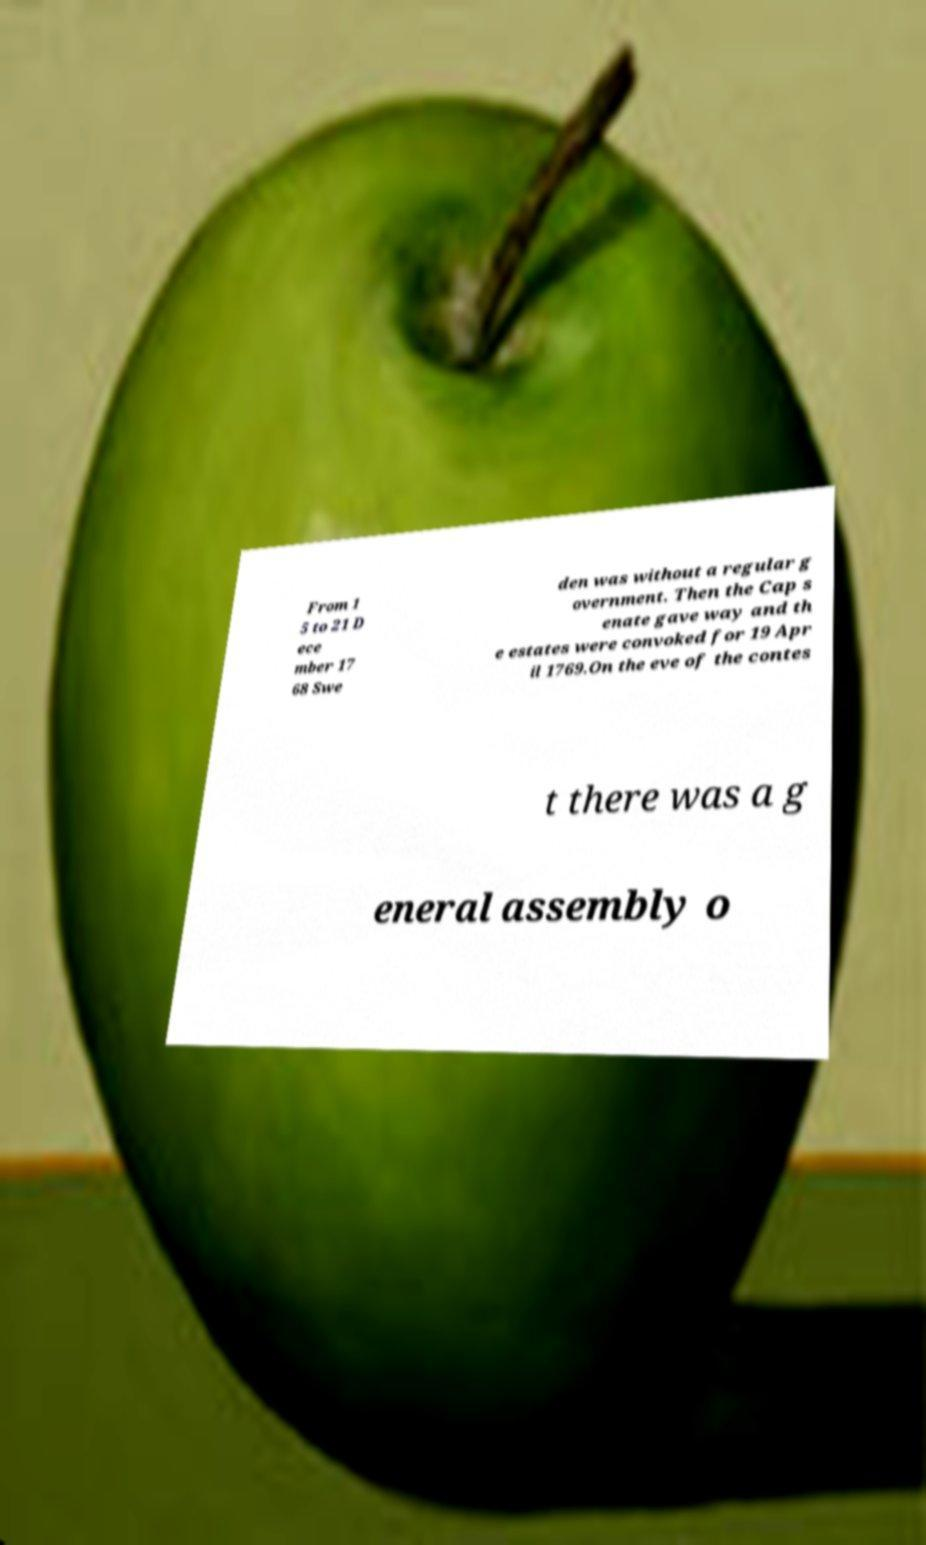For documentation purposes, I need the text within this image transcribed. Could you provide that? From 1 5 to 21 D ece mber 17 68 Swe den was without a regular g overnment. Then the Cap s enate gave way and th e estates were convoked for 19 Apr il 1769.On the eve of the contes t there was a g eneral assembly o 